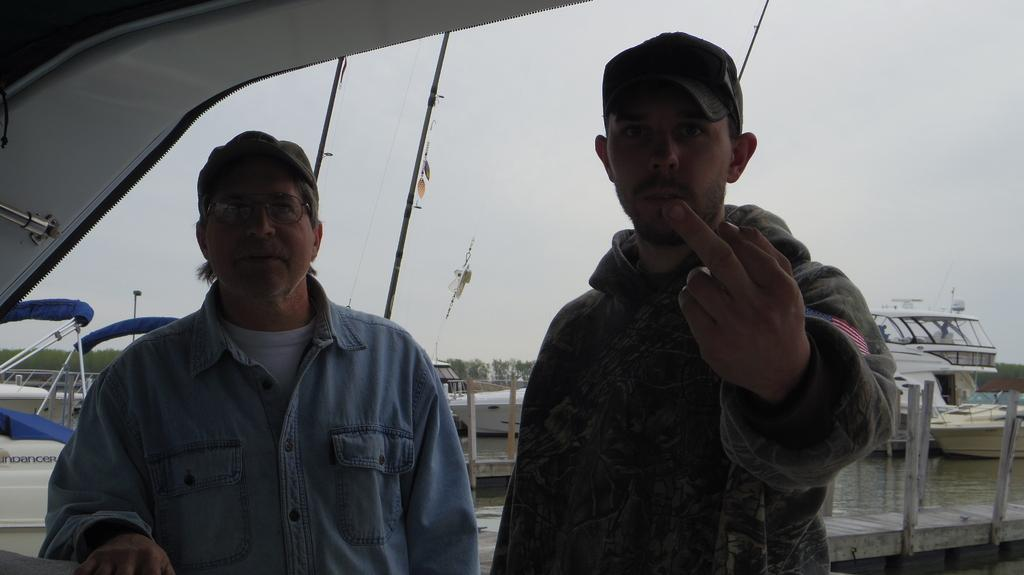How many people are in the image? There are two men in the image. What objects can be seen in the image besides the men? There are rods or poles visible in the image. What type of footwear are the men wearing? The boots are visible in the image. Are the boots submerged in water or above it? The boots are above the water. What can be seen in the background of the image? There are trees and the sky visible in the background of the image. What type of cracker is the girl holding in the image? There is no girl or cracker present in the image. What is the name of the partner of one of the men in the image? There is no mention of a partner or any names in the image. 